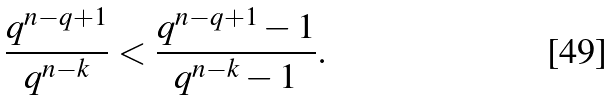<formula> <loc_0><loc_0><loc_500><loc_500>\frac { q ^ { n - q + 1 } } { q ^ { n - k } } < \frac { q ^ { n - q + 1 } - 1 } { q ^ { n - k } - 1 } .</formula> 